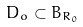Convert formula to latex. <formula><loc_0><loc_0><loc_500><loc_500>D _ { o } \subset B _ { R _ { 0 } }</formula> 